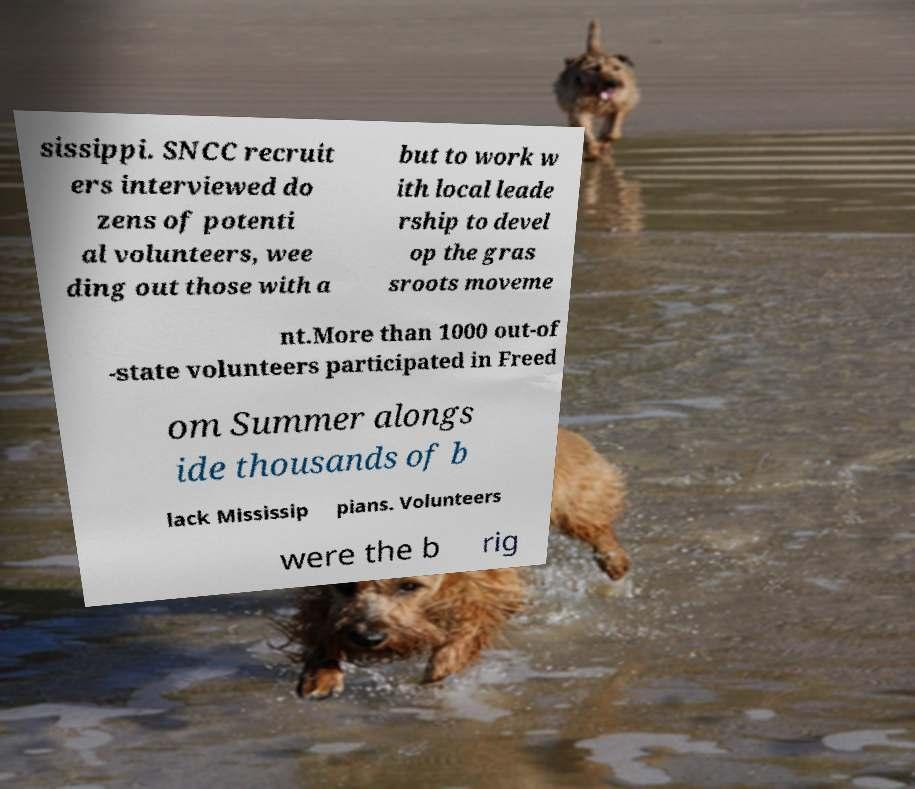What messages or text are displayed in this image? I need them in a readable, typed format. sissippi. SNCC recruit ers interviewed do zens of potenti al volunteers, wee ding out those with a but to work w ith local leade rship to devel op the gras sroots moveme nt.More than 1000 out-of -state volunteers participated in Freed om Summer alongs ide thousands of b lack Mississip pians. Volunteers were the b rig 